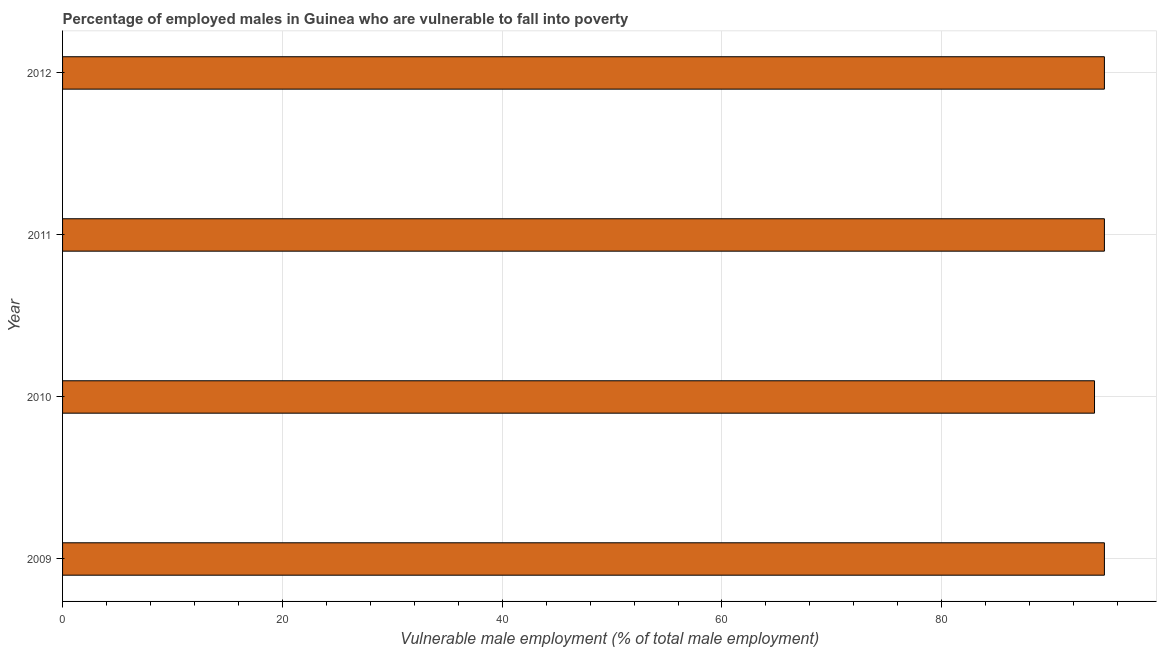Does the graph contain any zero values?
Your answer should be compact. No. What is the title of the graph?
Provide a short and direct response. Percentage of employed males in Guinea who are vulnerable to fall into poverty. What is the label or title of the X-axis?
Provide a succinct answer. Vulnerable male employment (% of total male employment). What is the percentage of employed males who are vulnerable to fall into poverty in 2012?
Offer a terse response. 94.8. Across all years, what is the maximum percentage of employed males who are vulnerable to fall into poverty?
Offer a terse response. 94.8. Across all years, what is the minimum percentage of employed males who are vulnerable to fall into poverty?
Your response must be concise. 93.9. What is the sum of the percentage of employed males who are vulnerable to fall into poverty?
Your answer should be compact. 378.3. What is the difference between the percentage of employed males who are vulnerable to fall into poverty in 2011 and 2012?
Keep it short and to the point. 0. What is the average percentage of employed males who are vulnerable to fall into poverty per year?
Your answer should be very brief. 94.58. What is the median percentage of employed males who are vulnerable to fall into poverty?
Keep it short and to the point. 94.8. Is the percentage of employed males who are vulnerable to fall into poverty in 2009 less than that in 2011?
Ensure brevity in your answer.  No. Is the difference between the percentage of employed males who are vulnerable to fall into poverty in 2010 and 2012 greater than the difference between any two years?
Make the answer very short. Yes. What is the difference between the highest and the second highest percentage of employed males who are vulnerable to fall into poverty?
Your answer should be very brief. 0. Is the sum of the percentage of employed males who are vulnerable to fall into poverty in 2009 and 2010 greater than the maximum percentage of employed males who are vulnerable to fall into poverty across all years?
Make the answer very short. Yes. Are all the bars in the graph horizontal?
Provide a short and direct response. Yes. What is the Vulnerable male employment (% of total male employment) in 2009?
Offer a very short reply. 94.8. What is the Vulnerable male employment (% of total male employment) in 2010?
Make the answer very short. 93.9. What is the Vulnerable male employment (% of total male employment) of 2011?
Offer a terse response. 94.8. What is the Vulnerable male employment (% of total male employment) in 2012?
Your response must be concise. 94.8. What is the difference between the Vulnerable male employment (% of total male employment) in 2009 and 2010?
Provide a short and direct response. 0.9. What is the difference between the Vulnerable male employment (% of total male employment) in 2009 and 2011?
Your response must be concise. 0. What is the difference between the Vulnerable male employment (% of total male employment) in 2009 and 2012?
Your answer should be compact. 0. What is the difference between the Vulnerable male employment (% of total male employment) in 2010 and 2011?
Offer a very short reply. -0.9. What is the difference between the Vulnerable male employment (% of total male employment) in 2010 and 2012?
Your response must be concise. -0.9. What is the ratio of the Vulnerable male employment (% of total male employment) in 2009 to that in 2010?
Provide a succinct answer. 1.01. What is the ratio of the Vulnerable male employment (% of total male employment) in 2010 to that in 2011?
Give a very brief answer. 0.99. What is the ratio of the Vulnerable male employment (% of total male employment) in 2010 to that in 2012?
Provide a short and direct response. 0.99. 